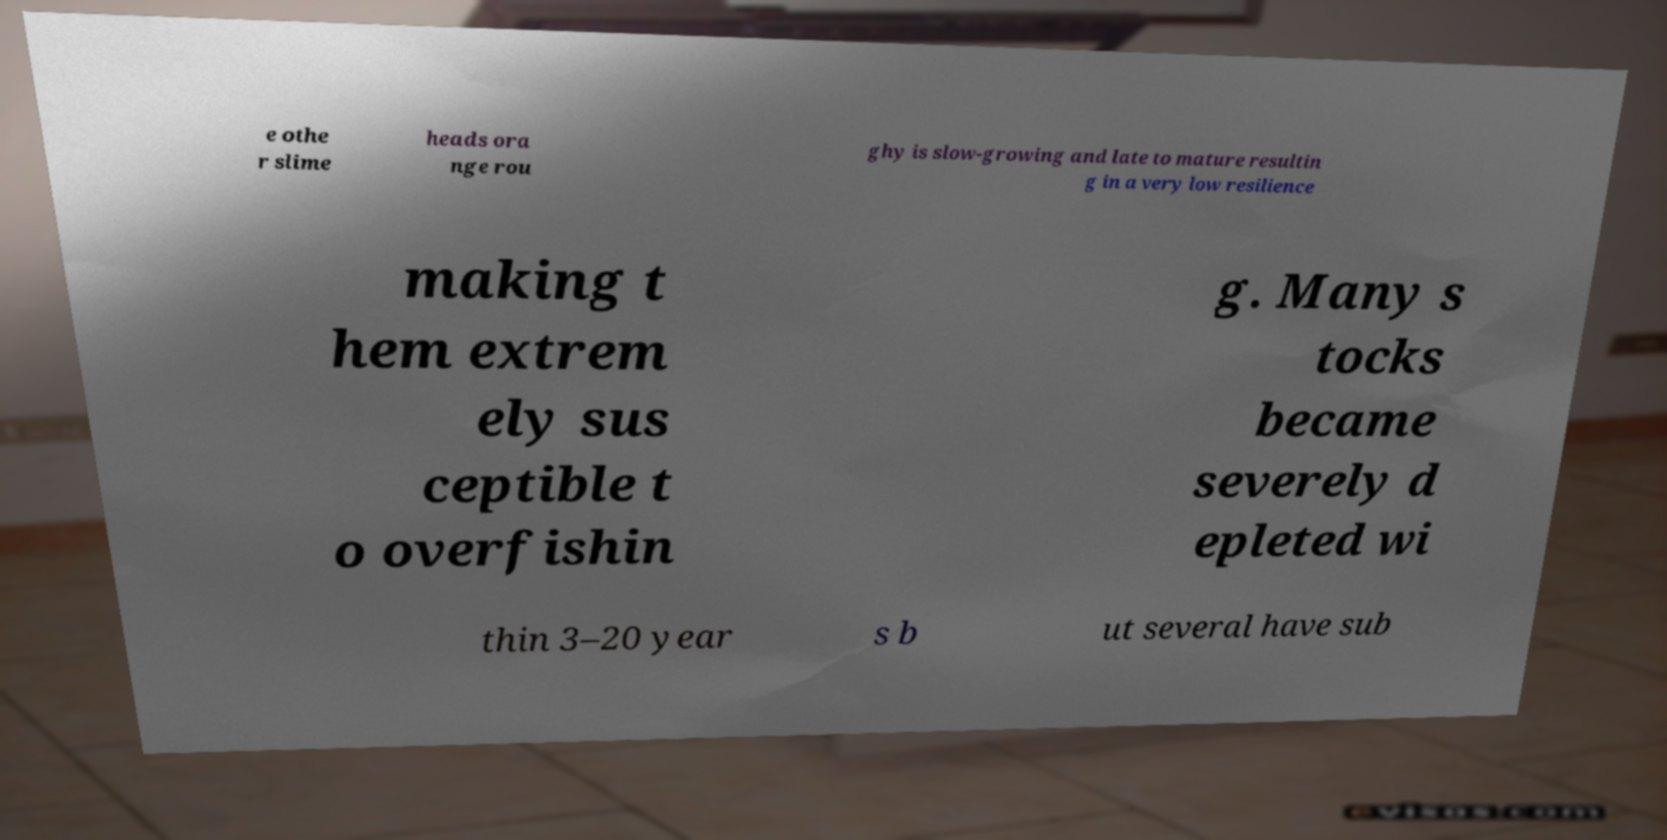Could you assist in decoding the text presented in this image and type it out clearly? e othe r slime heads ora nge rou ghy is slow-growing and late to mature resultin g in a very low resilience making t hem extrem ely sus ceptible t o overfishin g. Many s tocks became severely d epleted wi thin 3–20 year s b ut several have sub 